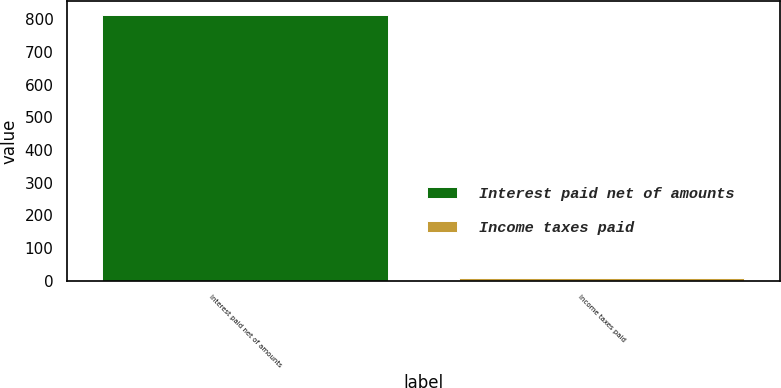<chart> <loc_0><loc_0><loc_500><loc_500><bar_chart><fcel>Interest paid net of amounts<fcel>Income taxes paid<nl><fcel>814<fcel>7<nl></chart> 